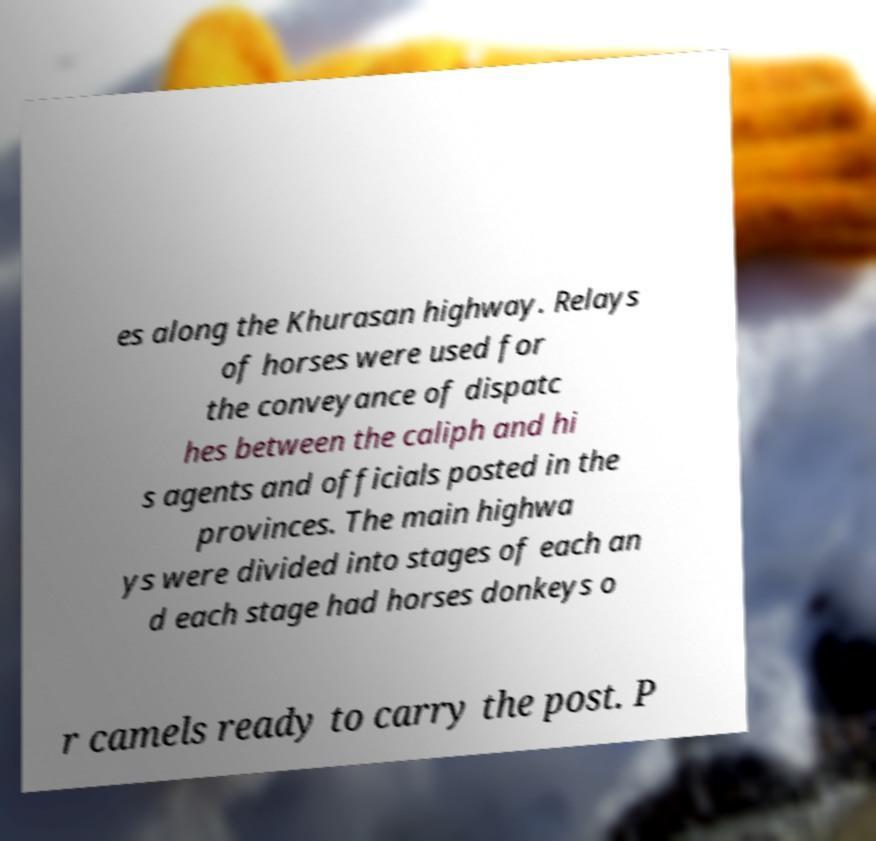Can you accurately transcribe the text from the provided image for me? es along the Khurasan highway. Relays of horses were used for the conveyance of dispatc hes between the caliph and hi s agents and officials posted in the provinces. The main highwa ys were divided into stages of each an d each stage had horses donkeys o r camels ready to carry the post. P 